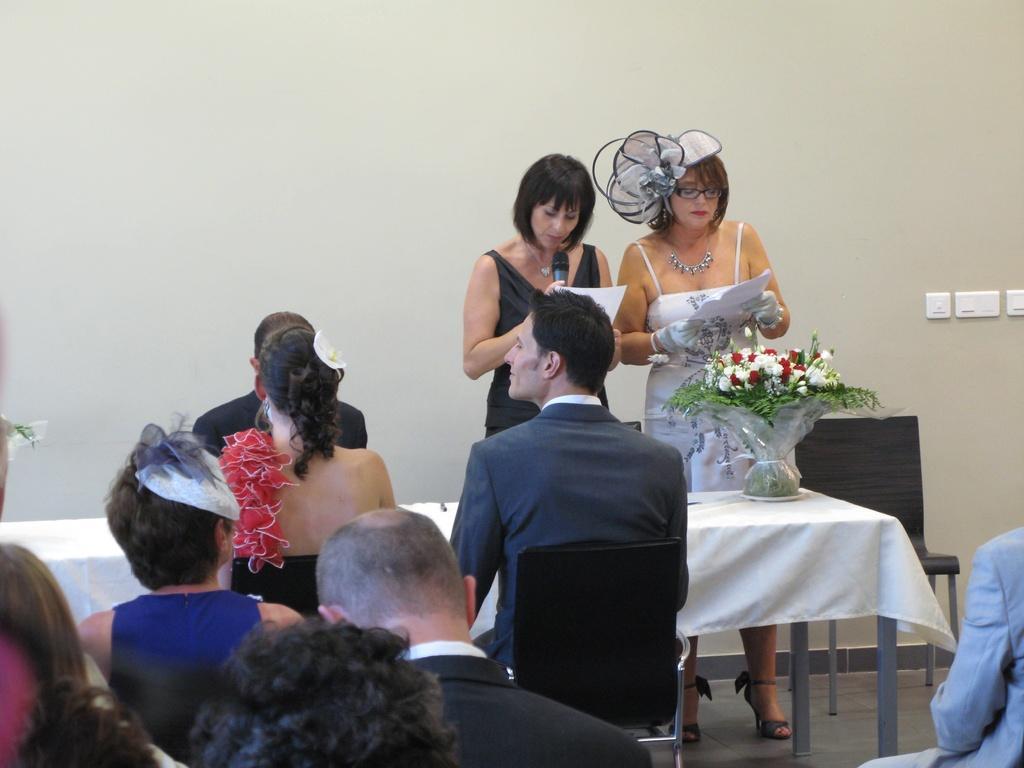Could you give a brief overview of what you see in this image? In the picture there are many people sitting on the chair to people are sitting in front of a table two people are standing in front of a table on the table there was a flowers vase a woman is talking in a microphone there is a wall behind the women. 